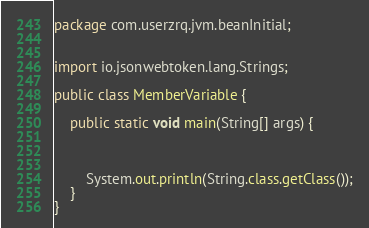Convert code to text. <code><loc_0><loc_0><loc_500><loc_500><_Java_>package com.userzrq.jvm.beanInitial;


import io.jsonwebtoken.lang.Strings;

public class MemberVariable {

    public static void main(String[] args) {



        System.out.println(String.class.getClass());
    }
}
</code> 